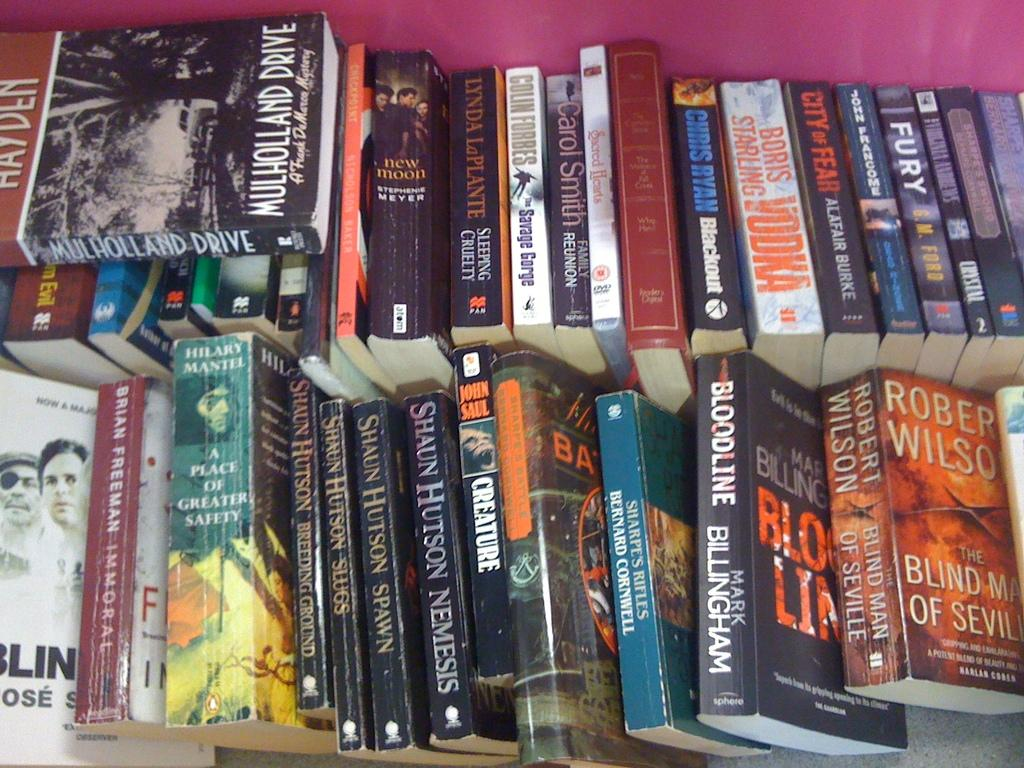Provide a one-sentence caption for the provided image. Two rows of sevral books stacked side to side with mullholland drive on the top stack. 